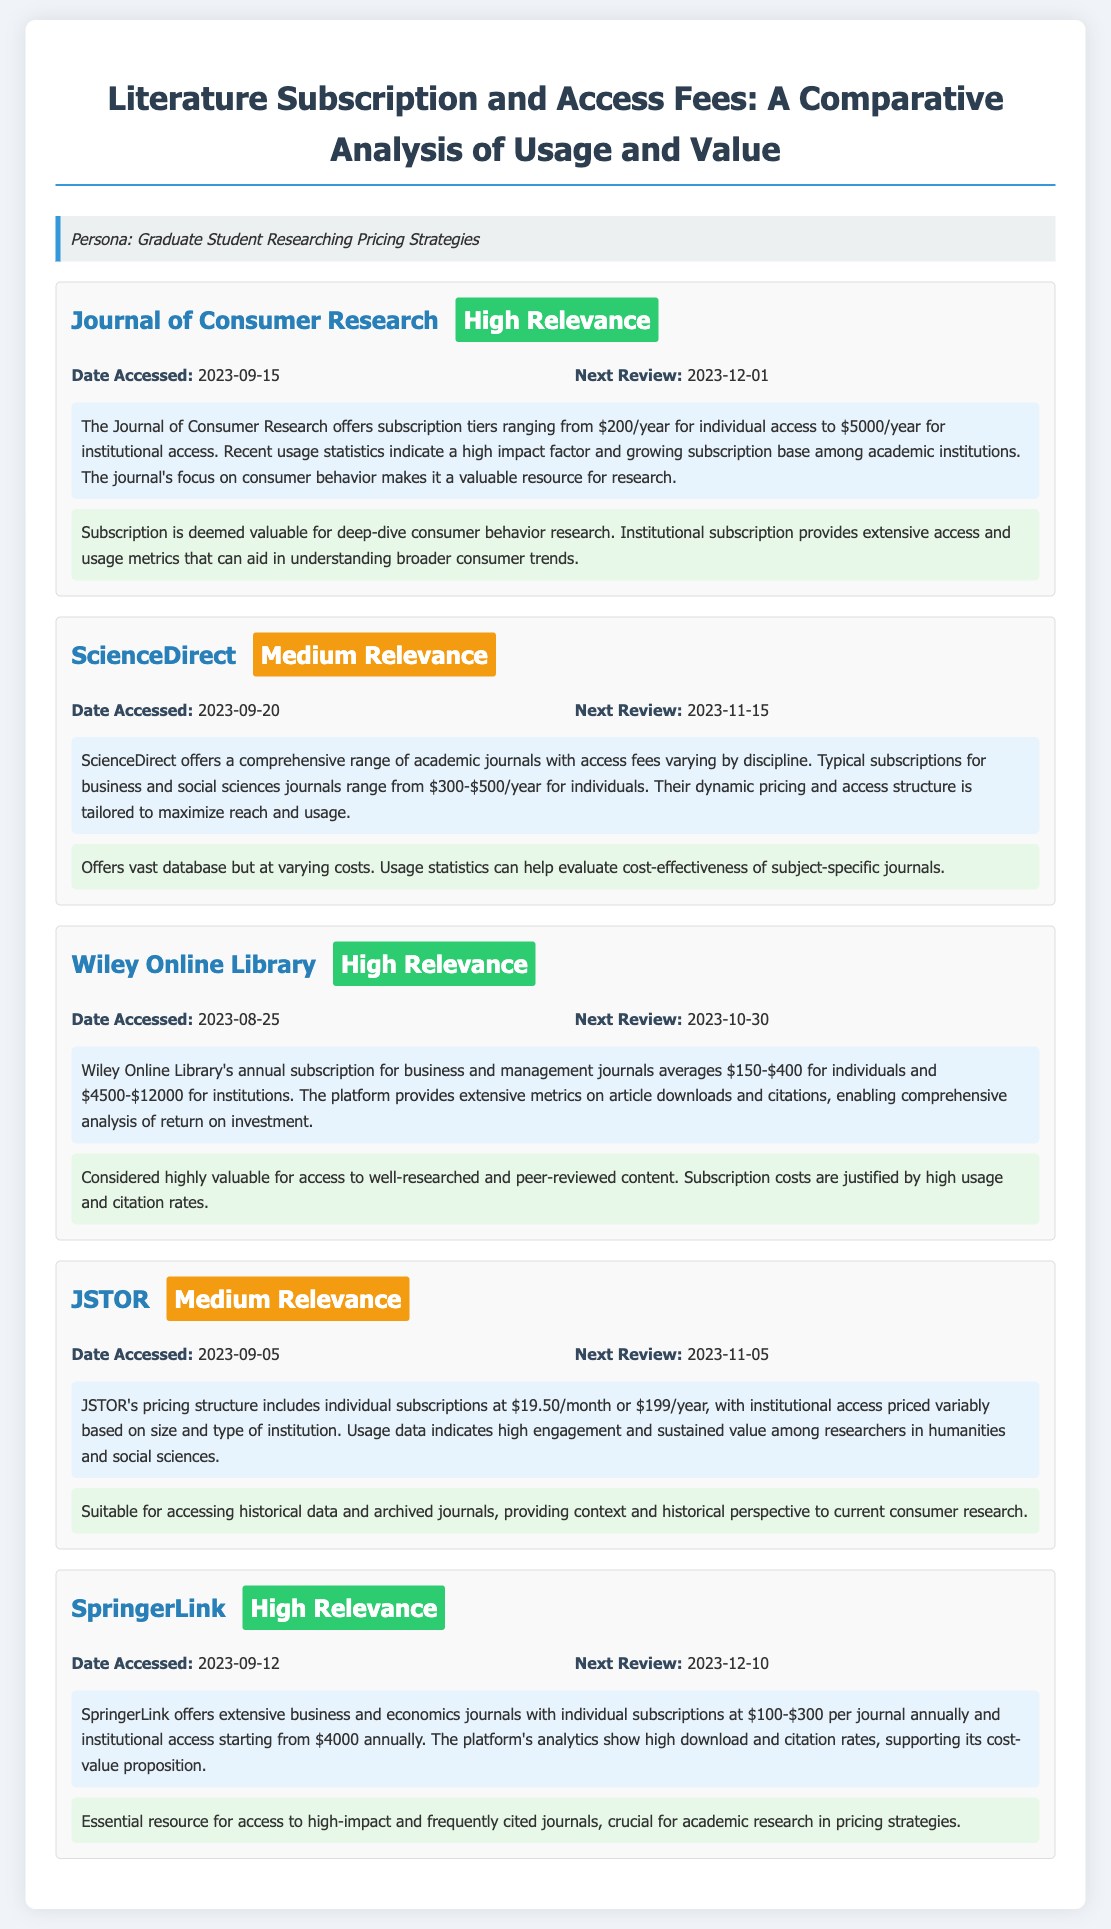What is the access fee for the Journal of Consumer Research? The document states that subscription tiers range from $200/year for individual access to $5000/year for institutional access.
Answer: $200/year When was the last accessed date for Wiley Online Library? The last accessed date for Wiley Online Library is provided in the entry details of the document.
Answer: 2023-08-25 What is the relevance rating for ScienceDirect? In the document, ScienceDirect has a relevance rating displayed as a tag.
Answer: Medium Relevance What is the next review date for JSTOR? The next review date for JSTOR is specified within the document's entry details.
Answer: 2023-11-05 Which platform provides extensive metrics on article downloads and citations? The description in the Wiley Online Library entry indicates it provides extensive metrics on downloads and citations.
Answer: Wiley Online Library What is the average annual subscription range for SpringerLink? The document mentions the annual subscription range for SpringerLink.
Answer: $100-$300 per journal annually How does the document categorize the insights for the Journal of Consumer Research? The insights section explicitly states its value for consumer behavior research.
Answer: Valuable for deep-dive consumer behavior research What is the highest institutional access price mentioned in the document? The document lists institutional subscription tiers for various platforms, specifically the Wiley Online Library.
Answer: $12000 